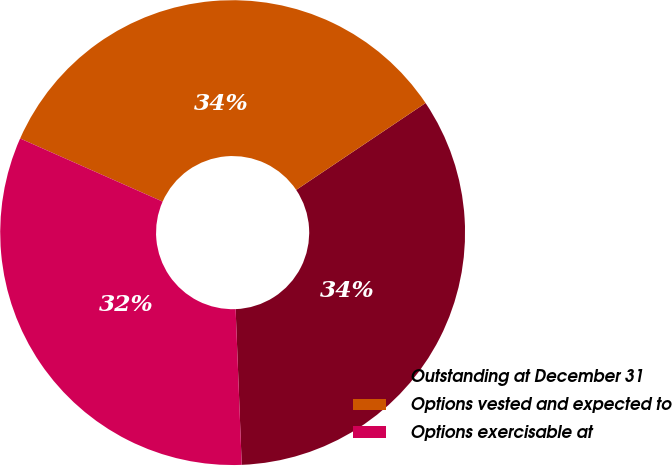Convert chart. <chart><loc_0><loc_0><loc_500><loc_500><pie_chart><fcel>Outstanding at December 31<fcel>Options vested and expected to<fcel>Options exercisable at<nl><fcel>33.79%<fcel>33.95%<fcel>32.26%<nl></chart> 